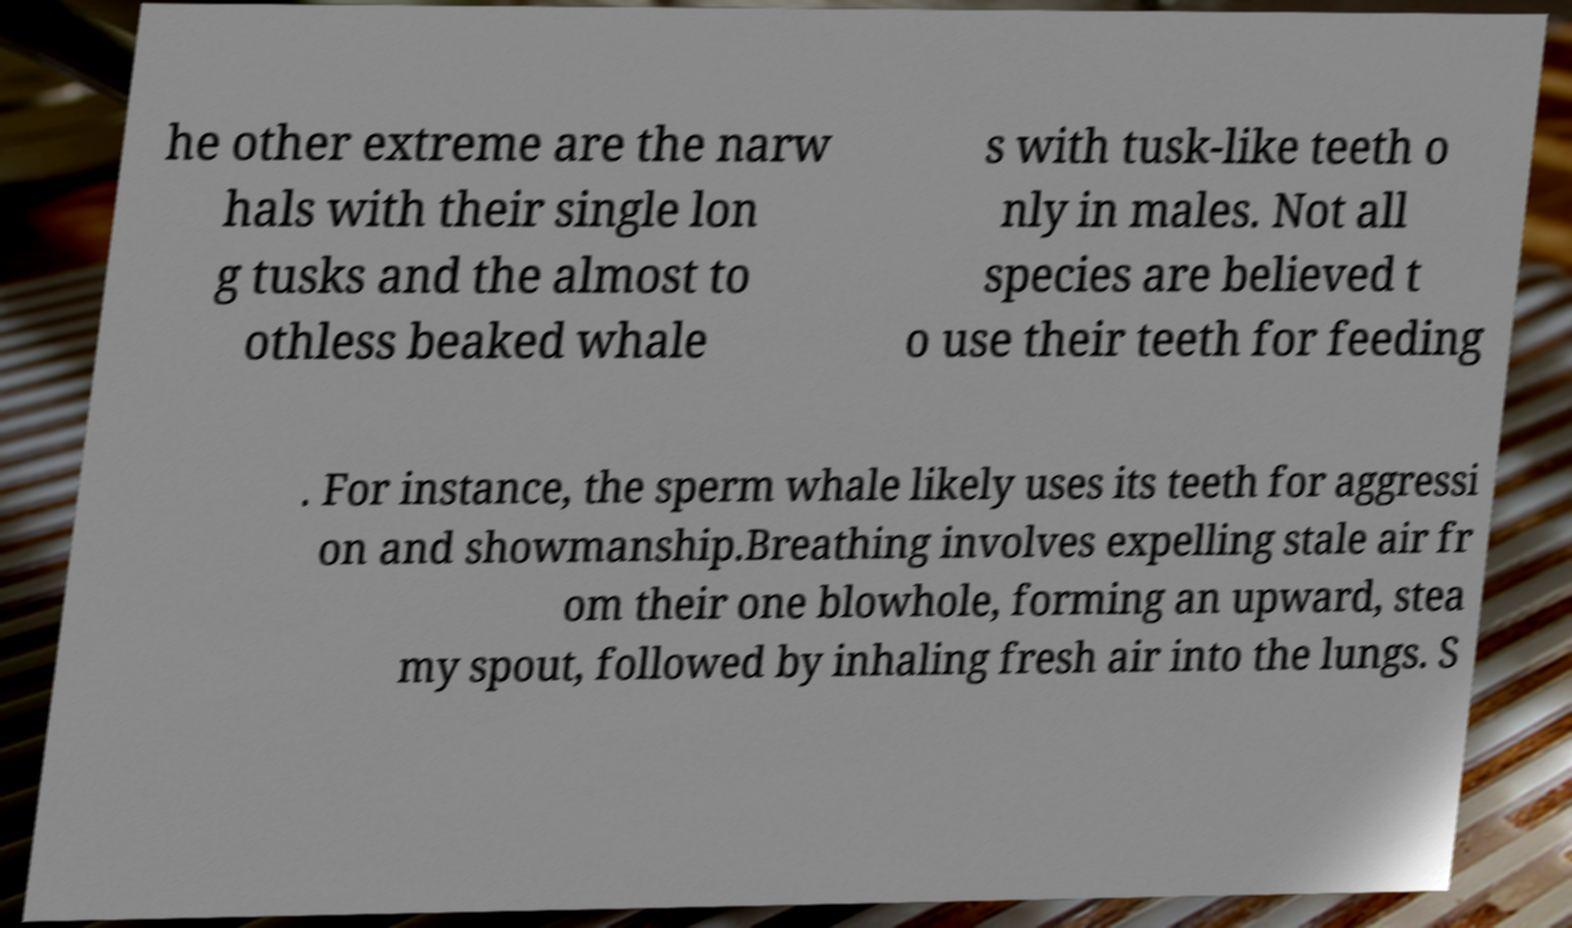Please identify and transcribe the text found in this image. he other extreme are the narw hals with their single lon g tusks and the almost to othless beaked whale s with tusk-like teeth o nly in males. Not all species are believed t o use their teeth for feeding . For instance, the sperm whale likely uses its teeth for aggressi on and showmanship.Breathing involves expelling stale air fr om their one blowhole, forming an upward, stea my spout, followed by inhaling fresh air into the lungs. S 